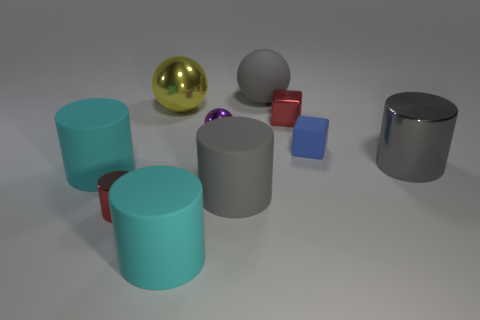What size is the block that is the same color as the small metal cylinder?
Offer a terse response. Small. What is the material of the large sphere that is the same color as the big shiny cylinder?
Provide a short and direct response. Rubber. How many other objects are there of the same color as the big metal cylinder?
Make the answer very short. 2. Is there a metallic thing that has the same color as the tiny metal cylinder?
Offer a very short reply. Yes. There is a gray matte cylinder; is its size the same as the cube behind the blue rubber cube?
Provide a succinct answer. No. There is a small metallic thing on the right side of the gray cylinder in front of the big metal object that is in front of the tiny purple object; what is its color?
Your answer should be very brief. Red. Is the red object behind the small blue matte block made of the same material as the blue block?
Offer a terse response. No. How many other objects are the same material as the small purple sphere?
Provide a short and direct response. 4. What material is the blue object that is the same size as the red block?
Your response must be concise. Rubber. Is the shape of the small red thing in front of the tiny red shiny cube the same as the big gray thing that is in front of the gray shiny cylinder?
Offer a very short reply. Yes. 